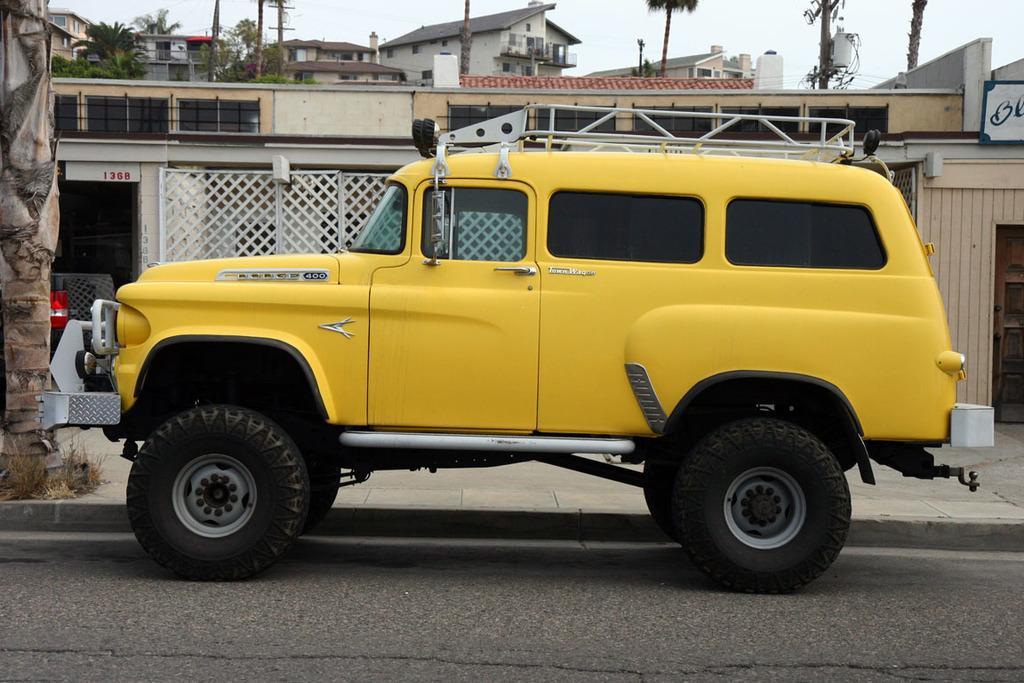Could you give a brief overview of what you see in this image? In this image there is a car parked on the road. Beside the road there is a walkway. Beside the walkway there are buildings, trees and poles. To the left there is a tree trunk on the walkway. At the top there is the sky. 